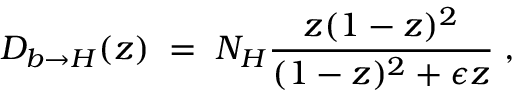<formula> <loc_0><loc_0><loc_500><loc_500>{ D _ { b \rightarrow H } ( z ) \, = \, N _ { H } { \frac { z ( 1 - z ) ^ { 2 } } { ( 1 - z ) ^ { 2 } + \epsilon z } } \, , }</formula> 